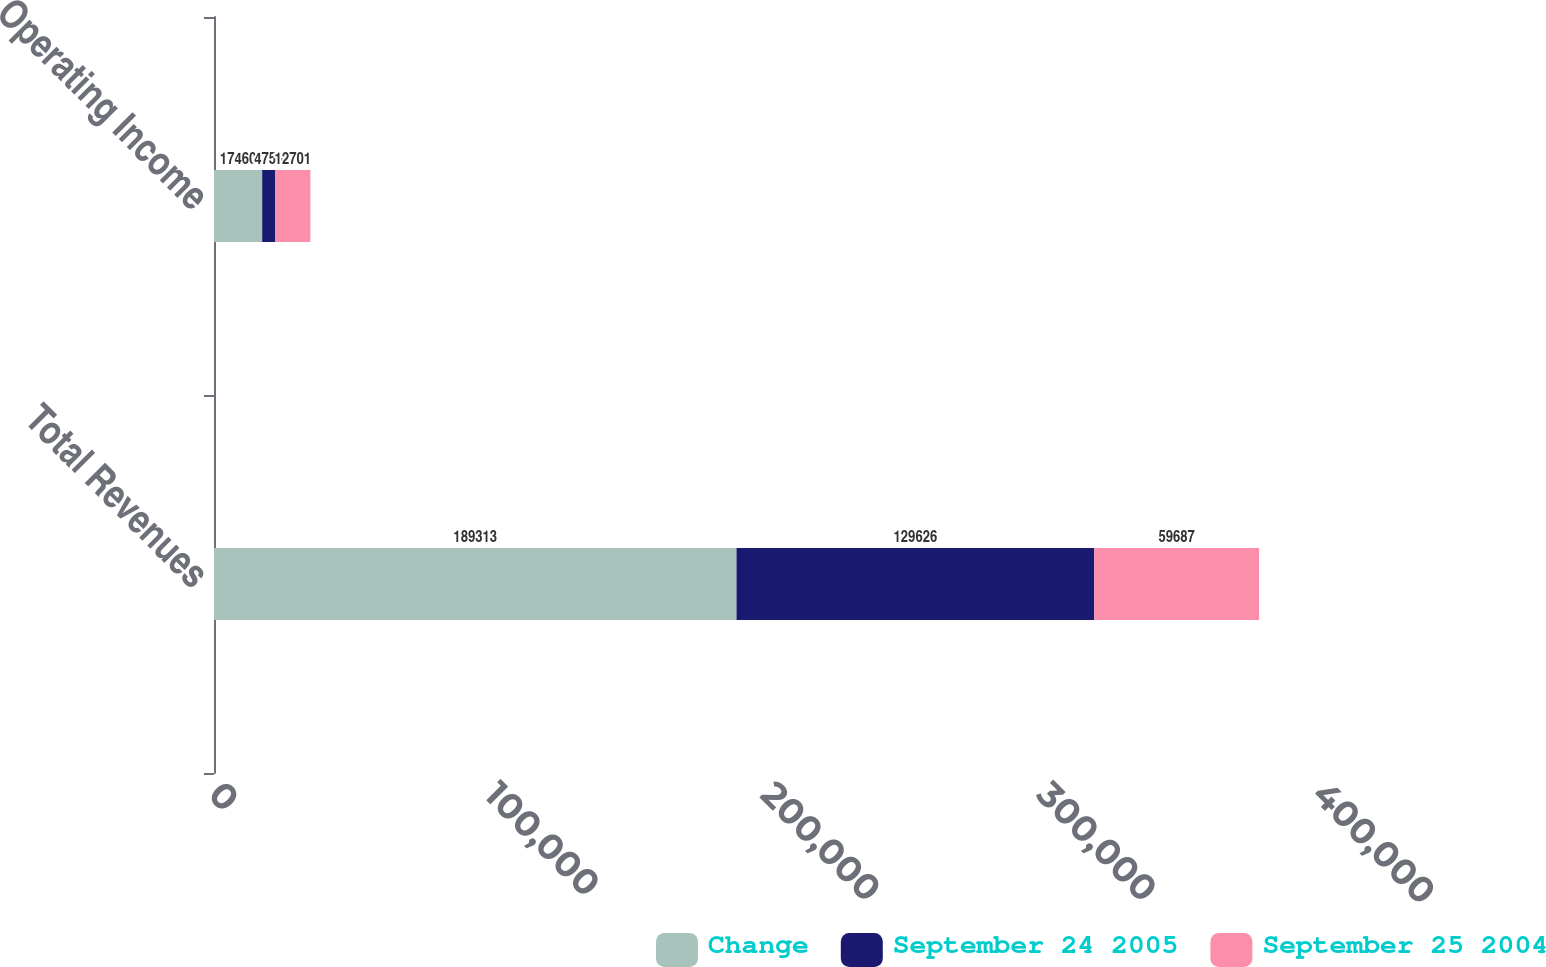<chart> <loc_0><loc_0><loc_500><loc_500><stacked_bar_chart><ecel><fcel>Total Revenues<fcel>Operating Income<nl><fcel>Change<fcel>189313<fcel>17460<nl><fcel>September 24 2005<fcel>129626<fcel>4759<nl><fcel>September 25 2004<fcel>59687<fcel>12701<nl></chart> 